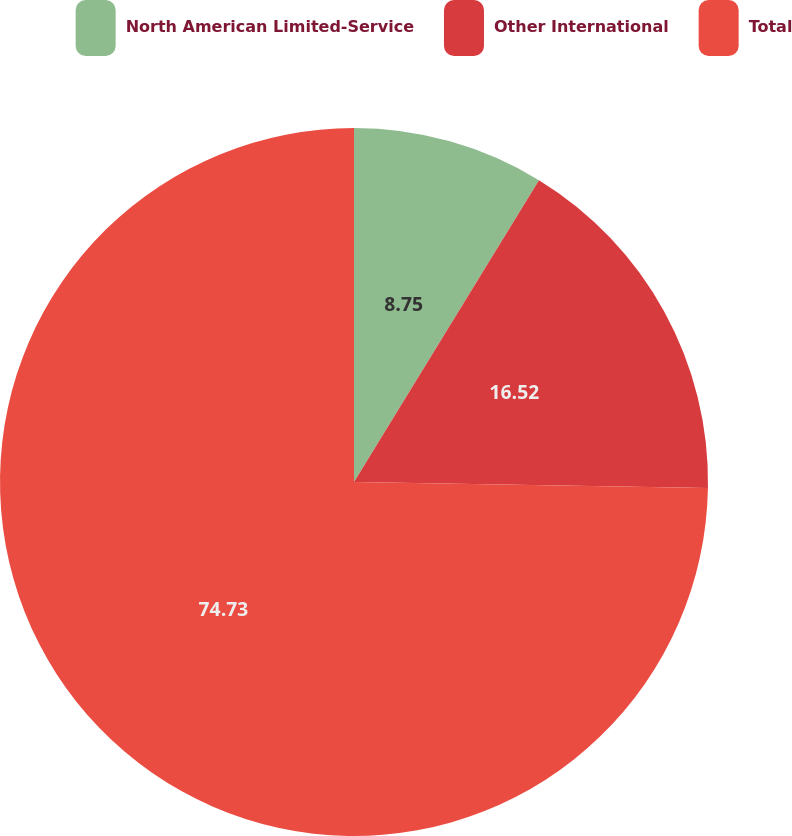Convert chart to OTSL. <chart><loc_0><loc_0><loc_500><loc_500><pie_chart><fcel>North American Limited-Service<fcel>Other International<fcel>Total<nl><fcel>8.75%<fcel>16.52%<fcel>74.73%<nl></chart> 